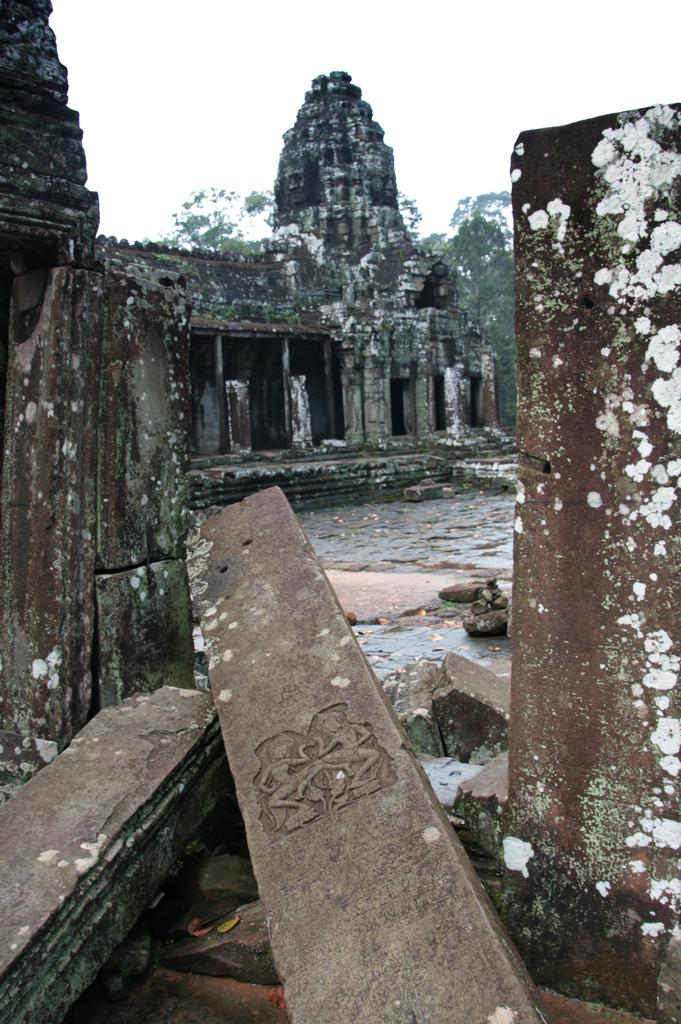What type of structure is depicted in the image? There is an ancient building in the image. What other elements can be seen in the image besides the building? There are trees, stones, and pillars in the image. What is visible in the background of the image? The sky is visible in the background of the image. What type of gun is being used to protect the territory in the image? There is no gun or territory present in the image; it features an ancient building, trees, stones, pillars, and the sky. 